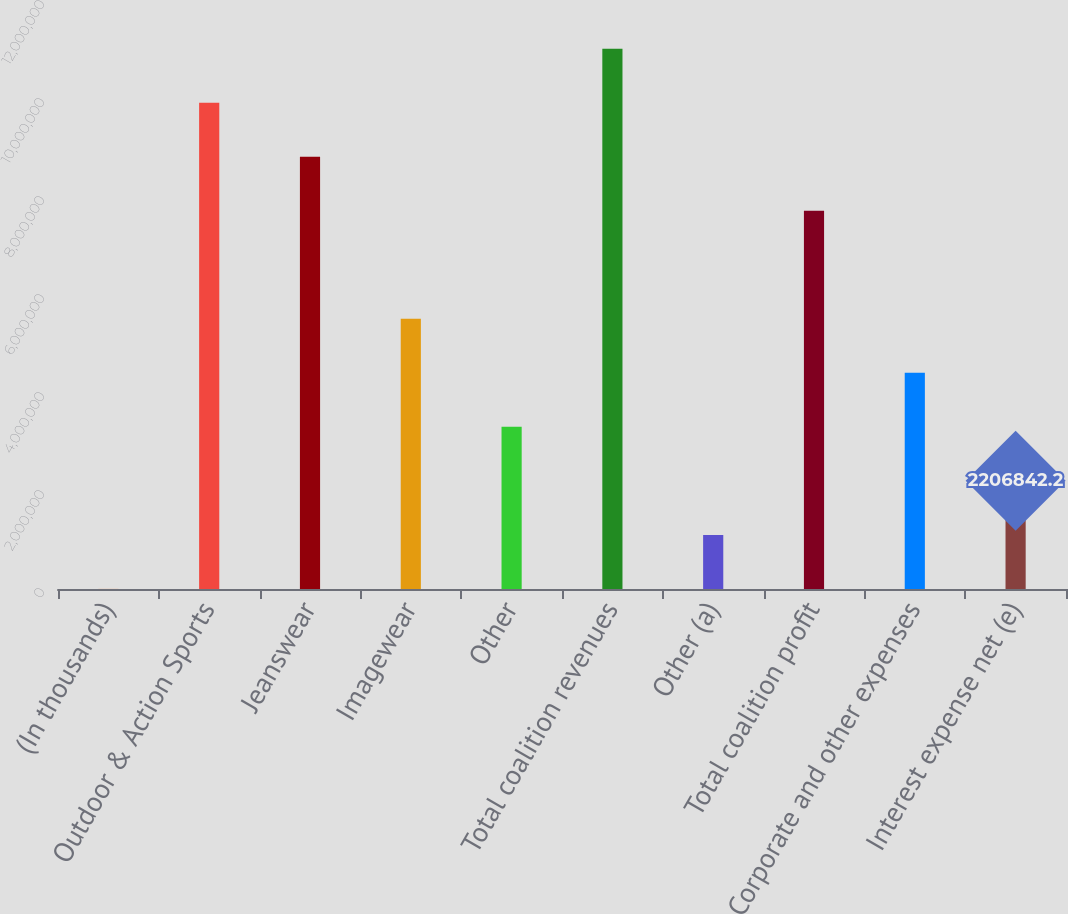<chart> <loc_0><loc_0><loc_500><loc_500><bar_chart><fcel>(In thousands)<fcel>Outdoor & Action Sports<fcel>Jeanswear<fcel>Imagewear<fcel>Other<fcel>Total coalition revenues<fcel>Other (a)<fcel>Total coalition profit<fcel>Corporate and other expenses<fcel>Interest expense net (e)<nl><fcel>2016<fcel>9.92373e+06<fcel>8.82132e+06<fcel>5.51408e+06<fcel>3.30926e+06<fcel>1.10261e+07<fcel>1.10443e+06<fcel>7.71891e+06<fcel>4.41167e+06<fcel>2.20684e+06<nl></chart> 